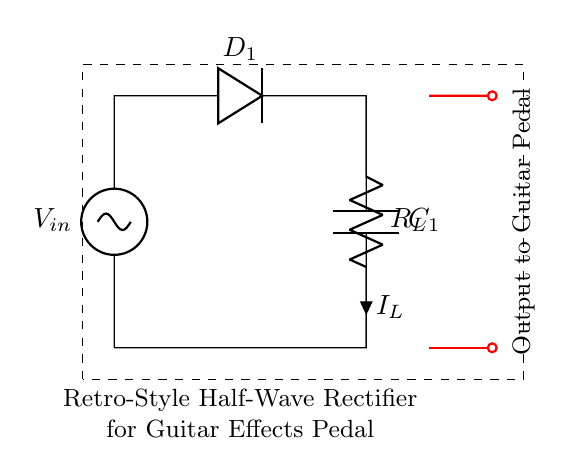What type of rectifier is shown in this circuit? The circuit is labeled as a "Retro-Style Half-Wave Rectifier" which indicates that it is a half-wave rectifier.
Answer: Half-Wave Rectifier What component is labeled as D1? The component labeled as D1 is a diode, which allows current to flow in one direction only.
Answer: Diode What is the purpose of C1 in this circuit? C1 is a capacitor, which is used to smooth out the output voltage after rectification by reducing ripple.
Answer: Smoothing capacitor What is the load resistor in this circuit called? The load resistor is labeled as R_L, indicating that it is the load resistor for the circuit.
Answer: R_L What happens to the output voltage during the negative cycle of the input? During the negative cycle, the diode blocks the current, resulting in zero output voltage.
Answer: Zero voltage Why is a half-wave rectifier preferred for simple guitar effects pedals? Half-wave rectifiers are simpler and cheaper; they require fewer components and are adequate for low-power applications like guitar pedals.
Answer: Simplicity and cost-efficiency 